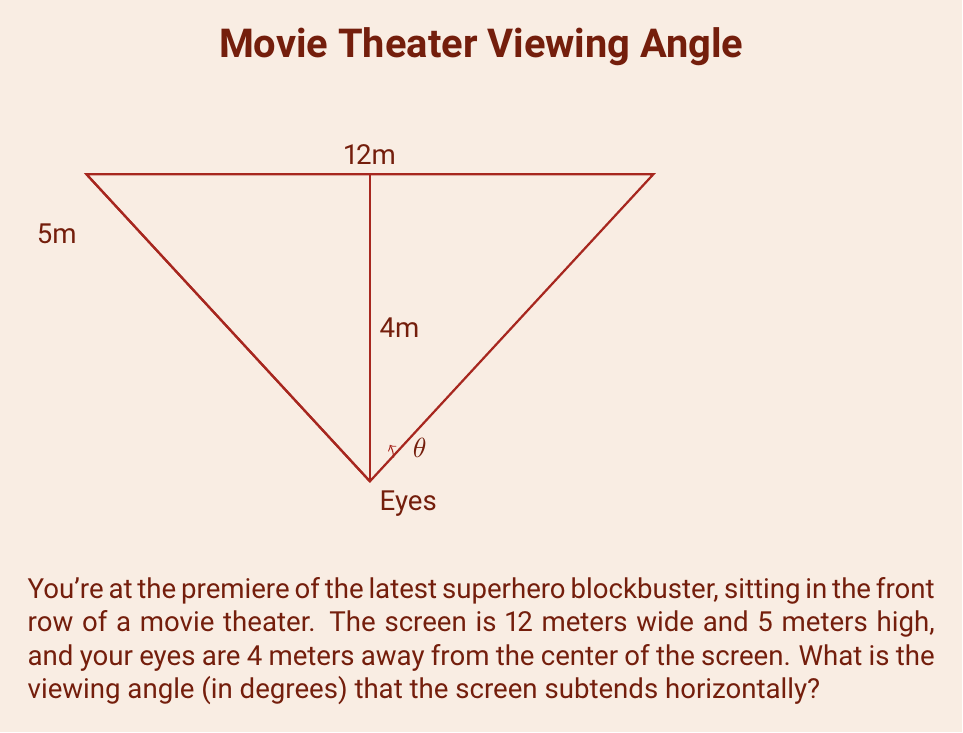Solve this math problem. Let's approach this step-by-step:

1) We can treat this as a right triangle problem. The base of the triangle is half the width of the screen (since we're looking at the angle from the center), and the height is the distance from our eyes to the screen.

2) Half the width of the screen is:
   $\frac{12}{2} = 6$ meters

3) We can use the tangent function to find half of the viewing angle:
   $\tan(\frac{\theta}{2}) = \frac{\text{opposite}}{\text{adjacent}} = \frac{6}{4}$

4) To solve for $\theta$, we need to use the inverse tangent (arctangent) function and multiply by 2:
   $\theta = 2 \cdot \arctan(\frac{6}{4})$

5) Let's calculate this:
   $\theta = 2 \cdot \arctan(1.5)$
   $\theta = 2 \cdot 56.3099325^{\circ}$
   $\theta = 112.6198650^{\circ}$

6) Rounding to two decimal places:
   $\theta \approx 112.62^{\circ}$

This wide angle explains why sitting in the front row can sometimes feel overwhelming, especially for action-packed superhero movies!
Answer: $112.62^{\circ}$ 